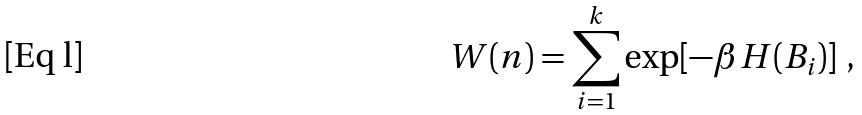<formula> <loc_0><loc_0><loc_500><loc_500>W ( n ) = \sum _ { i = 1 } ^ { k } \exp [ - \beta H ( B _ { i } ) ] \ ,</formula> 